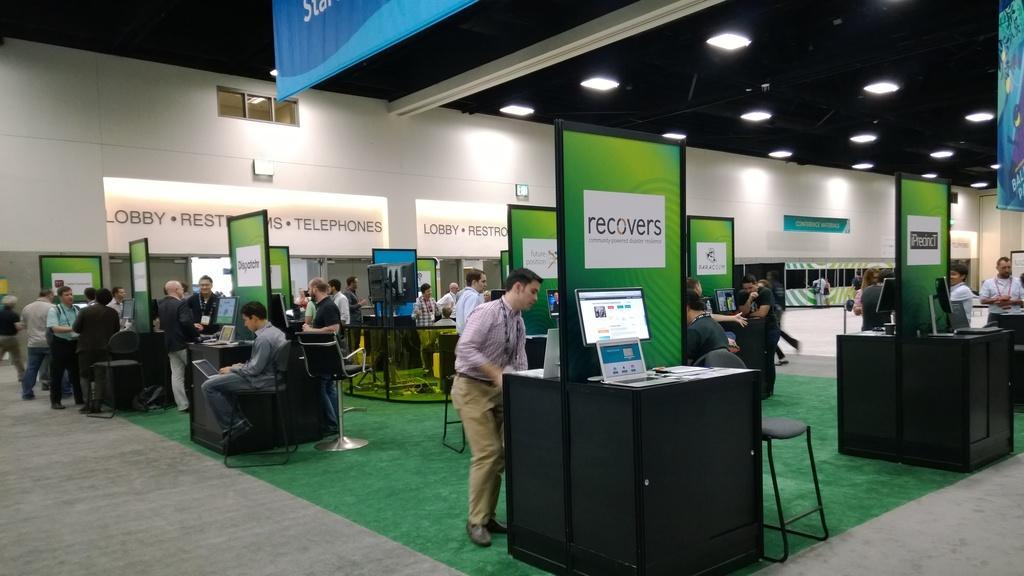How would you summarize this image in a sentence or two? In the foreground of this image, there are people standing on the floor and sitting on the chairs around desk like objects on which, there are monitors screens, laptops and few papers. In the background, there are people standing and sitting, wall, aboard, a banner and lights to the ceiling. 